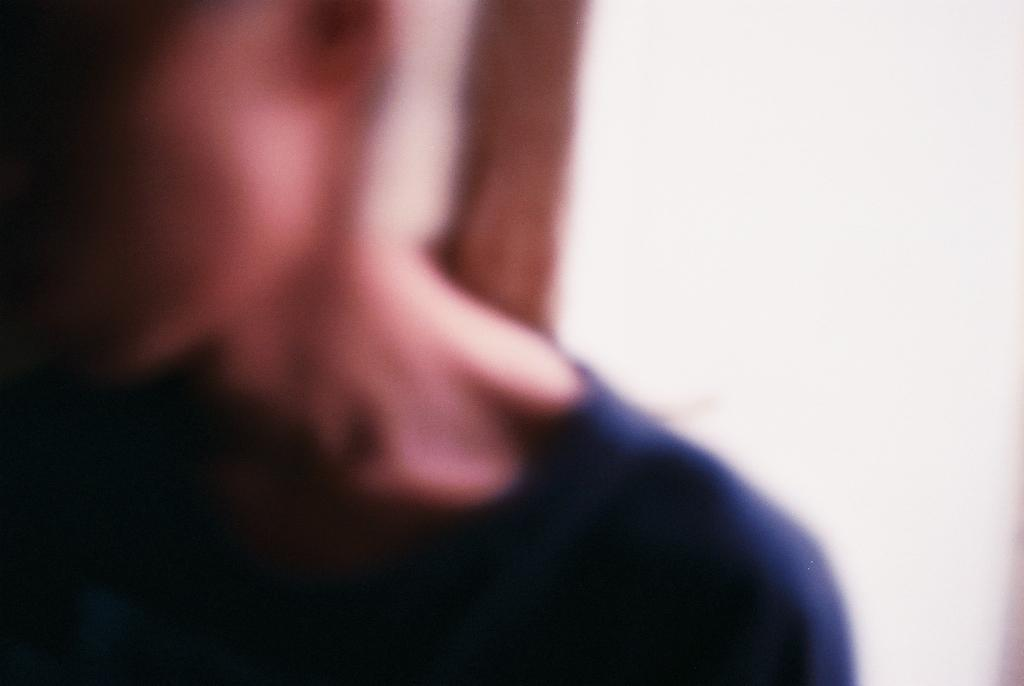What is the main subject of the image? There is a person in the image. What type of jewel is hanging from the icicle in the image? There is no jewel or icicle present in the image; it only features a person. 